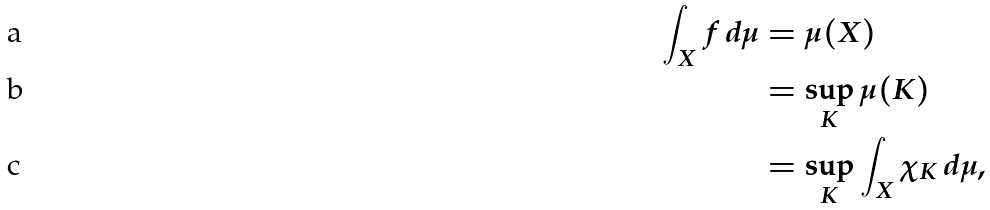<formula> <loc_0><loc_0><loc_500><loc_500>\int _ { X } f \, d \mu & = \mu ( X ) \\ & = \sup _ { K } \mu ( K ) \\ & = \sup _ { K } \int _ { X } \chi _ { K } \, d \mu ,</formula> 